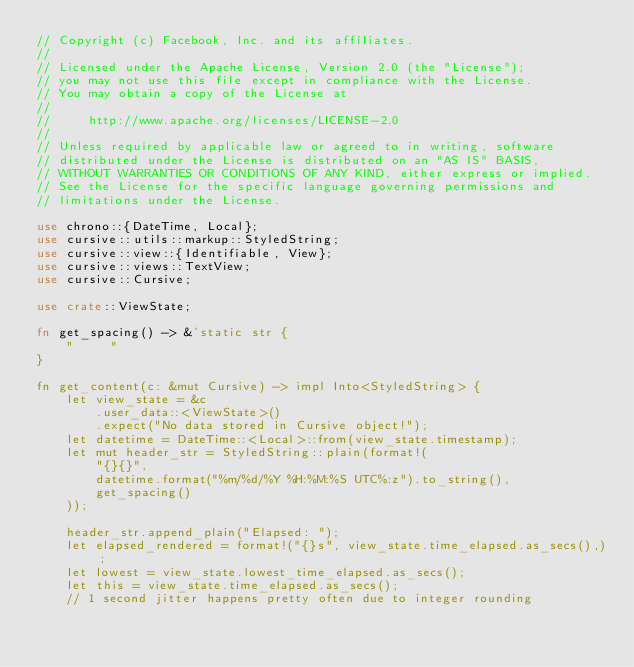Convert code to text. <code><loc_0><loc_0><loc_500><loc_500><_Rust_>// Copyright (c) Facebook, Inc. and its affiliates.
//
// Licensed under the Apache License, Version 2.0 (the "License");
// you may not use this file except in compliance with the License.
// You may obtain a copy of the License at
//
//     http://www.apache.org/licenses/LICENSE-2.0
//
// Unless required by applicable law or agreed to in writing, software
// distributed under the License is distributed on an "AS IS" BASIS,
// WITHOUT WARRANTIES OR CONDITIONS OF ANY KIND, either express or implied.
// See the License for the specific language governing permissions and
// limitations under the License.

use chrono::{DateTime, Local};
use cursive::utils::markup::StyledString;
use cursive::view::{Identifiable, View};
use cursive::views::TextView;
use cursive::Cursive;

use crate::ViewState;

fn get_spacing() -> &'static str {
    "     "
}

fn get_content(c: &mut Cursive) -> impl Into<StyledString> {
    let view_state = &c
        .user_data::<ViewState>()
        .expect("No data stored in Cursive object!");
    let datetime = DateTime::<Local>::from(view_state.timestamp);
    let mut header_str = StyledString::plain(format!(
        "{}{}",
        datetime.format("%m/%d/%Y %H:%M:%S UTC%:z").to_string(),
        get_spacing()
    ));

    header_str.append_plain("Elapsed: ");
    let elapsed_rendered = format!("{}s", view_state.time_elapsed.as_secs(),);
    let lowest = view_state.lowest_time_elapsed.as_secs();
    let this = view_state.time_elapsed.as_secs();
    // 1 second jitter happens pretty often due to integer rounding</code> 